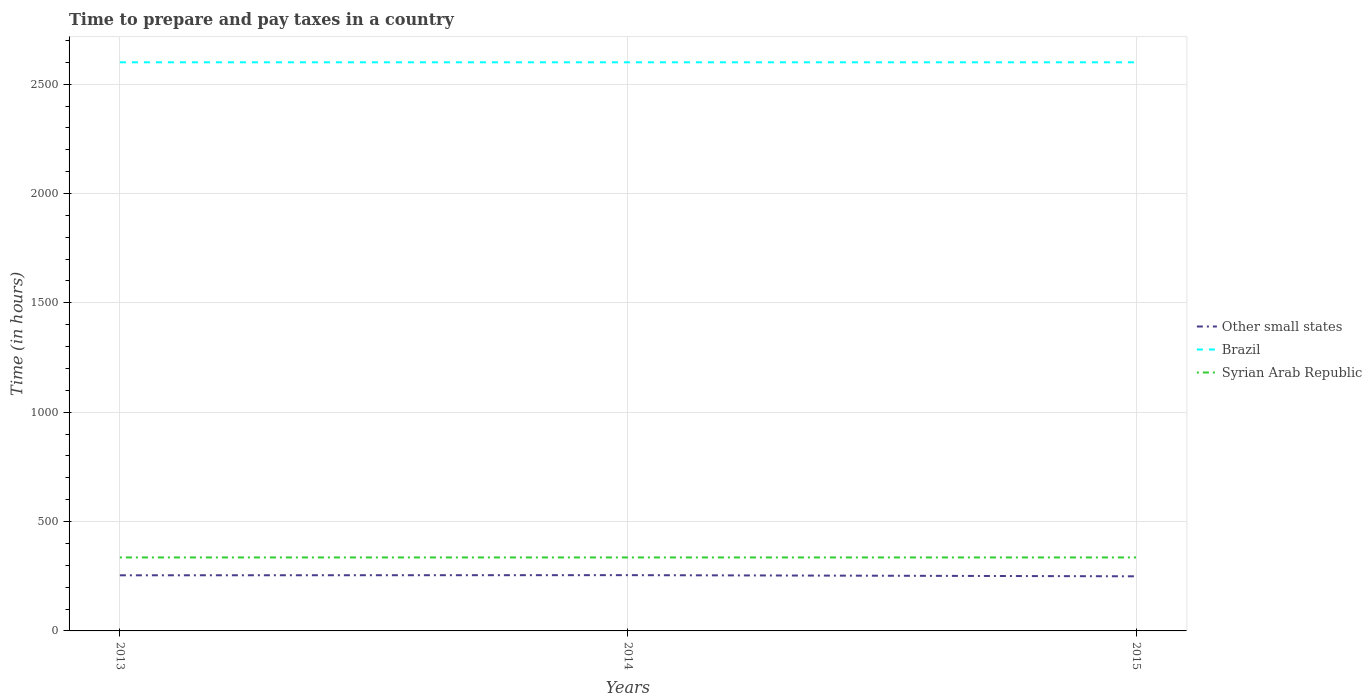How many different coloured lines are there?
Your answer should be very brief. 3. Does the line corresponding to Syrian Arab Republic intersect with the line corresponding to Brazil?
Keep it short and to the point. No. Is the number of lines equal to the number of legend labels?
Provide a succinct answer. Yes. Across all years, what is the maximum number of hours required to prepare and pay taxes in Brazil?
Your response must be concise. 2600. In which year was the number of hours required to prepare and pay taxes in Syrian Arab Republic maximum?
Your response must be concise. 2013. What is the total number of hours required to prepare and pay taxes in Syrian Arab Republic in the graph?
Your answer should be compact. 0. What is the difference between the highest and the second highest number of hours required to prepare and pay taxes in Other small states?
Ensure brevity in your answer.  5.31. What is the difference between the highest and the lowest number of hours required to prepare and pay taxes in Other small states?
Keep it short and to the point. 2. Is the number of hours required to prepare and pay taxes in Syrian Arab Republic strictly greater than the number of hours required to prepare and pay taxes in Brazil over the years?
Provide a short and direct response. Yes. How many lines are there?
Your answer should be very brief. 3. What is the difference between two consecutive major ticks on the Y-axis?
Provide a succinct answer. 500. What is the title of the graph?
Provide a short and direct response. Time to prepare and pay taxes in a country. Does "Middle East & North Africa (developing only)" appear as one of the legend labels in the graph?
Your answer should be very brief. No. What is the label or title of the Y-axis?
Your answer should be compact. Time (in hours). What is the Time (in hours) in Other small states in 2013?
Your answer should be compact. 254.33. What is the Time (in hours) of Brazil in 2013?
Provide a succinct answer. 2600. What is the Time (in hours) in Syrian Arab Republic in 2013?
Your response must be concise. 336. What is the Time (in hours) of Other small states in 2014?
Your answer should be compact. 255. What is the Time (in hours) of Brazil in 2014?
Keep it short and to the point. 2600. What is the Time (in hours) in Syrian Arab Republic in 2014?
Ensure brevity in your answer.  336. What is the Time (in hours) in Other small states in 2015?
Provide a succinct answer. 249.69. What is the Time (in hours) in Brazil in 2015?
Offer a terse response. 2600. What is the Time (in hours) in Syrian Arab Republic in 2015?
Offer a terse response. 336. Across all years, what is the maximum Time (in hours) of Other small states?
Provide a short and direct response. 255. Across all years, what is the maximum Time (in hours) of Brazil?
Your response must be concise. 2600. Across all years, what is the maximum Time (in hours) in Syrian Arab Republic?
Ensure brevity in your answer.  336. Across all years, what is the minimum Time (in hours) of Other small states?
Provide a short and direct response. 249.69. Across all years, what is the minimum Time (in hours) of Brazil?
Provide a short and direct response. 2600. Across all years, what is the minimum Time (in hours) in Syrian Arab Republic?
Ensure brevity in your answer.  336. What is the total Time (in hours) of Other small states in the graph?
Provide a short and direct response. 759.03. What is the total Time (in hours) of Brazil in the graph?
Offer a terse response. 7800. What is the total Time (in hours) of Syrian Arab Republic in the graph?
Give a very brief answer. 1008. What is the difference between the Time (in hours) in Syrian Arab Republic in 2013 and that in 2014?
Offer a very short reply. 0. What is the difference between the Time (in hours) of Other small states in 2013 and that in 2015?
Provide a succinct answer. 4.64. What is the difference between the Time (in hours) of Syrian Arab Republic in 2013 and that in 2015?
Keep it short and to the point. 0. What is the difference between the Time (in hours) of Other small states in 2014 and that in 2015?
Provide a short and direct response. 5.31. What is the difference between the Time (in hours) of Syrian Arab Republic in 2014 and that in 2015?
Your answer should be very brief. 0. What is the difference between the Time (in hours) in Other small states in 2013 and the Time (in hours) in Brazil in 2014?
Your response must be concise. -2345.67. What is the difference between the Time (in hours) in Other small states in 2013 and the Time (in hours) in Syrian Arab Republic in 2014?
Offer a terse response. -81.67. What is the difference between the Time (in hours) of Brazil in 2013 and the Time (in hours) of Syrian Arab Republic in 2014?
Make the answer very short. 2264. What is the difference between the Time (in hours) of Other small states in 2013 and the Time (in hours) of Brazil in 2015?
Your answer should be very brief. -2345.67. What is the difference between the Time (in hours) of Other small states in 2013 and the Time (in hours) of Syrian Arab Republic in 2015?
Ensure brevity in your answer.  -81.67. What is the difference between the Time (in hours) in Brazil in 2013 and the Time (in hours) in Syrian Arab Republic in 2015?
Your answer should be compact. 2264. What is the difference between the Time (in hours) of Other small states in 2014 and the Time (in hours) of Brazil in 2015?
Your answer should be very brief. -2345. What is the difference between the Time (in hours) in Other small states in 2014 and the Time (in hours) in Syrian Arab Republic in 2015?
Keep it short and to the point. -81. What is the difference between the Time (in hours) of Brazil in 2014 and the Time (in hours) of Syrian Arab Republic in 2015?
Provide a succinct answer. 2264. What is the average Time (in hours) of Other small states per year?
Ensure brevity in your answer.  253.01. What is the average Time (in hours) in Brazil per year?
Offer a very short reply. 2600. What is the average Time (in hours) of Syrian Arab Republic per year?
Give a very brief answer. 336. In the year 2013, what is the difference between the Time (in hours) of Other small states and Time (in hours) of Brazil?
Offer a very short reply. -2345.67. In the year 2013, what is the difference between the Time (in hours) in Other small states and Time (in hours) in Syrian Arab Republic?
Your answer should be compact. -81.67. In the year 2013, what is the difference between the Time (in hours) in Brazil and Time (in hours) in Syrian Arab Republic?
Give a very brief answer. 2264. In the year 2014, what is the difference between the Time (in hours) in Other small states and Time (in hours) in Brazil?
Make the answer very short. -2345. In the year 2014, what is the difference between the Time (in hours) of Other small states and Time (in hours) of Syrian Arab Republic?
Your response must be concise. -81. In the year 2014, what is the difference between the Time (in hours) in Brazil and Time (in hours) in Syrian Arab Republic?
Give a very brief answer. 2264. In the year 2015, what is the difference between the Time (in hours) in Other small states and Time (in hours) in Brazil?
Make the answer very short. -2350.31. In the year 2015, what is the difference between the Time (in hours) in Other small states and Time (in hours) in Syrian Arab Republic?
Your answer should be compact. -86.31. In the year 2015, what is the difference between the Time (in hours) of Brazil and Time (in hours) of Syrian Arab Republic?
Ensure brevity in your answer.  2264. What is the ratio of the Time (in hours) in Other small states in 2013 to that in 2014?
Offer a very short reply. 1. What is the ratio of the Time (in hours) of Other small states in 2013 to that in 2015?
Your answer should be compact. 1.02. What is the ratio of the Time (in hours) of Syrian Arab Republic in 2013 to that in 2015?
Your answer should be very brief. 1. What is the ratio of the Time (in hours) in Other small states in 2014 to that in 2015?
Give a very brief answer. 1.02. What is the ratio of the Time (in hours) in Syrian Arab Republic in 2014 to that in 2015?
Your answer should be very brief. 1. What is the difference between the highest and the second highest Time (in hours) of Brazil?
Your answer should be compact. 0. What is the difference between the highest and the second highest Time (in hours) in Syrian Arab Republic?
Keep it short and to the point. 0. What is the difference between the highest and the lowest Time (in hours) of Other small states?
Keep it short and to the point. 5.31. What is the difference between the highest and the lowest Time (in hours) in Brazil?
Ensure brevity in your answer.  0. 